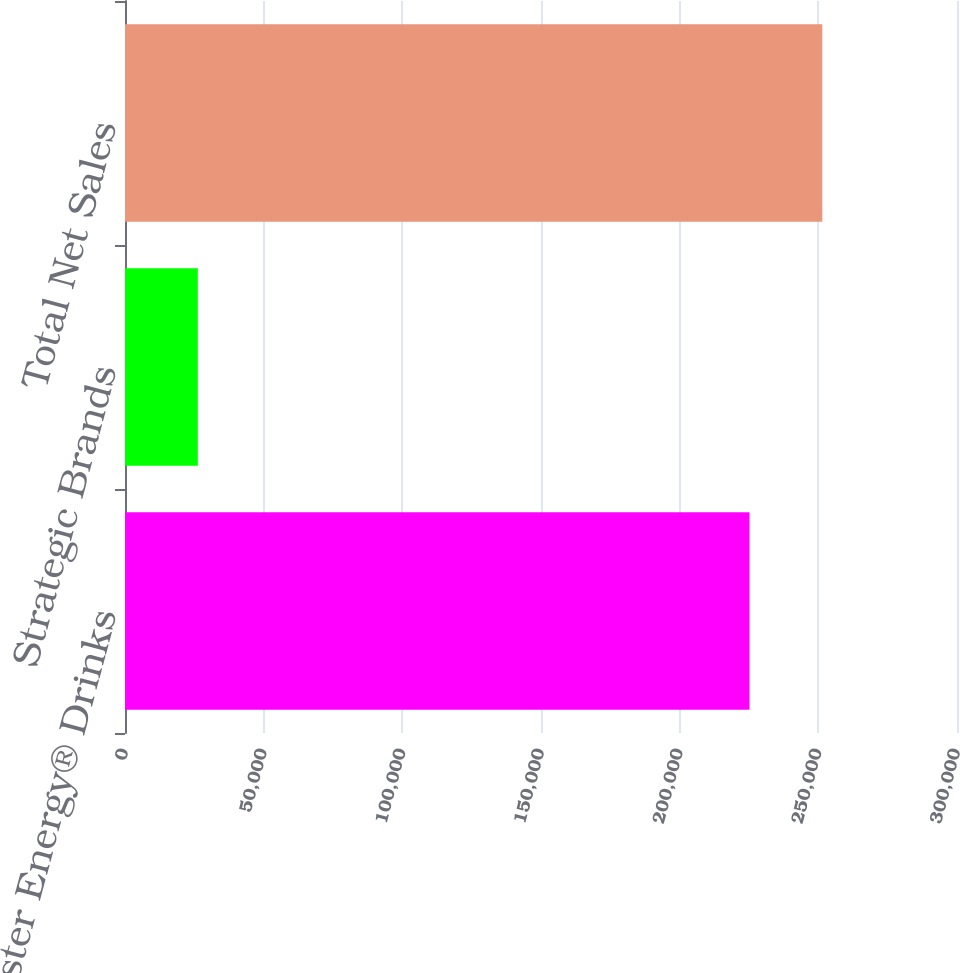Convert chart to OTSL. <chart><loc_0><loc_0><loc_500><loc_500><bar_chart><fcel>Monster Energy® Drinks<fcel>Strategic Brands<fcel>Total Net Sales<nl><fcel>225172<fcel>26254<fcel>251426<nl></chart> 